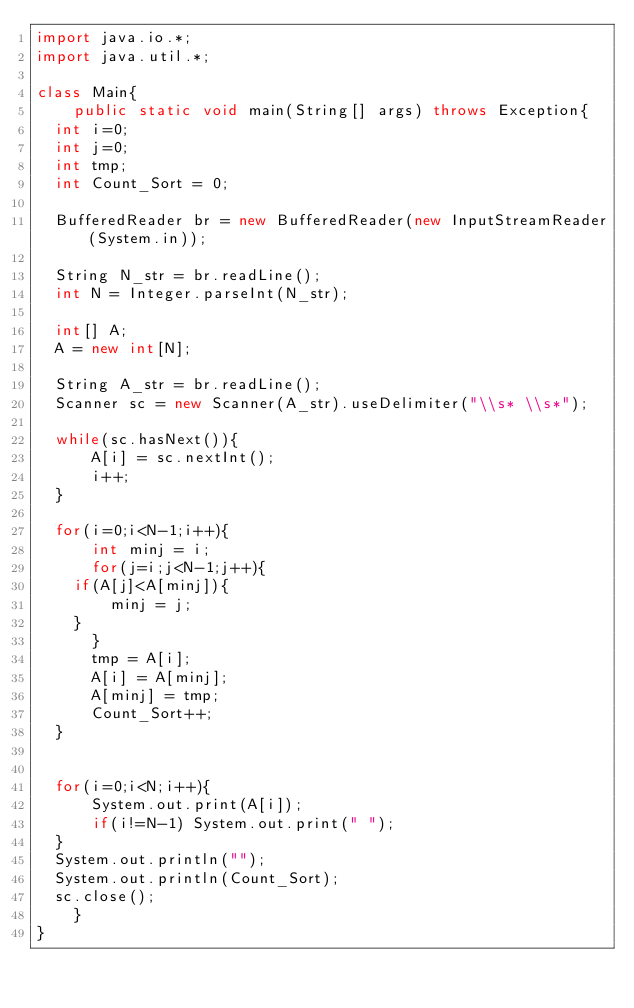Convert code to text. <code><loc_0><loc_0><loc_500><loc_500><_Java_>import java.io.*;
import java.util.*;

class Main{
    public static void main(String[] args) throws Exception{
	int i=0;
	int j=0;
	int tmp;
	int Count_Sort = 0;
	
	BufferedReader br = new BufferedReader(new InputStreamReader(System.in));

	String N_str = br.readLine();
	int N = Integer.parseInt(N_str);
	
	int[] A;
	A = new int[N];
	
	String A_str = br.readLine();
	Scanner sc = new Scanner(A_str).useDelimiter("\\s* \\s*");
	
	while(sc.hasNext()){
	    A[i] = sc.nextInt();
	    i++;
	}

	for(i=0;i<N-1;i++){
	    int minj = i;
	    for(j=i;j<N-1;j++){
		if(A[j]<A[minj]){
		    minj = j;
		}
	    }
	    tmp = A[i];
	    A[i] = A[minj];
	    A[minj] = tmp;
	    Count_Sort++;
	}
	    

	for(i=0;i<N;i++){
	    System.out.print(A[i]);
	    if(i!=N-1) System.out.print(" ");
	}
	System.out.println("");
	System.out.println(Count_Sort);
	sc.close();
    }
}
</code> 